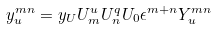Convert formula to latex. <formula><loc_0><loc_0><loc_500><loc_500>y _ { u } ^ { m n } = y _ { U } U ^ { u } _ { m } U ^ { q } _ { n } U _ { 0 } \epsilon ^ { m + n } Y _ { u } ^ { m n }</formula> 